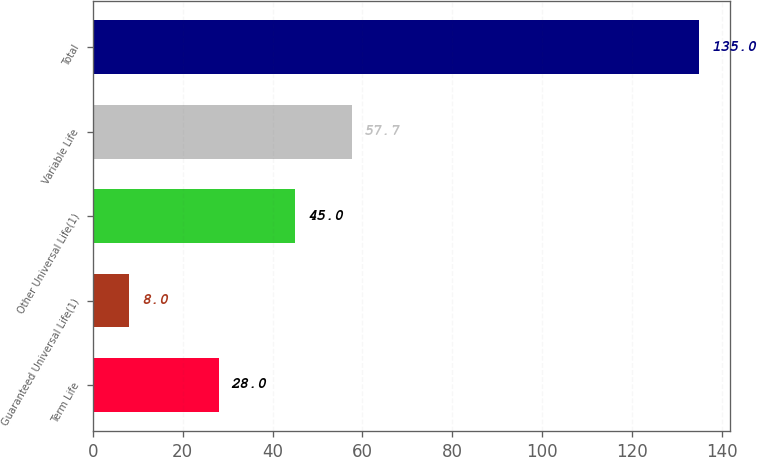Convert chart to OTSL. <chart><loc_0><loc_0><loc_500><loc_500><bar_chart><fcel>Term Life<fcel>Guaranteed Universal Life(1)<fcel>Other Universal Life(1)<fcel>Variable Life<fcel>Total<nl><fcel>28<fcel>8<fcel>45<fcel>57.7<fcel>135<nl></chart> 